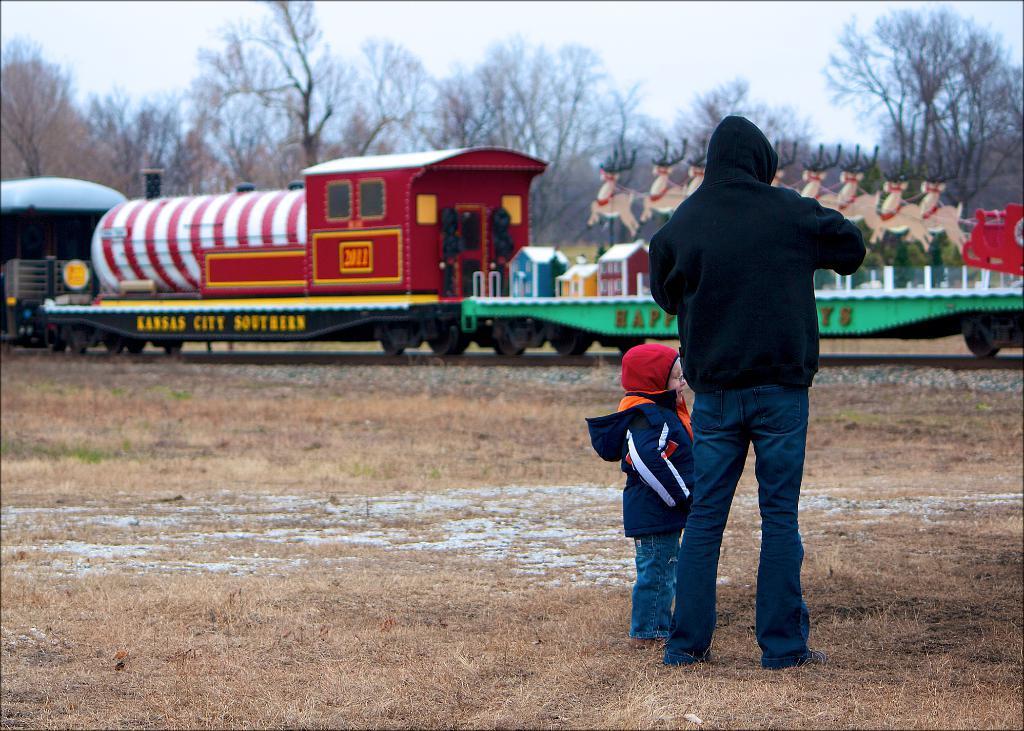How would you summarize this image in a sentence or two? In this image we can see a person and a kid standing on the ground, there is a train and few objects on the train and there are trees and the sky in the background. 